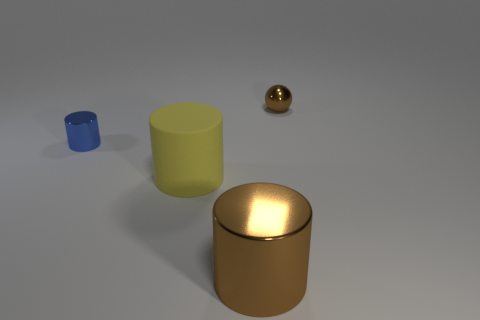Subtract all shiny cylinders. How many cylinders are left? 1 Subtract all blue cylinders. How many cylinders are left? 2 Add 2 brown metallic objects. How many objects exist? 6 Subtract all spheres. How many objects are left? 3 Subtract 2 cylinders. How many cylinders are left? 1 Subtract all red cylinders. Subtract all purple balls. How many cylinders are left? 3 Subtract all small blue cylinders. Subtract all metal things. How many objects are left? 0 Add 2 big objects. How many big objects are left? 4 Add 3 large purple metal objects. How many large purple metal objects exist? 3 Subtract 0 cyan balls. How many objects are left? 4 